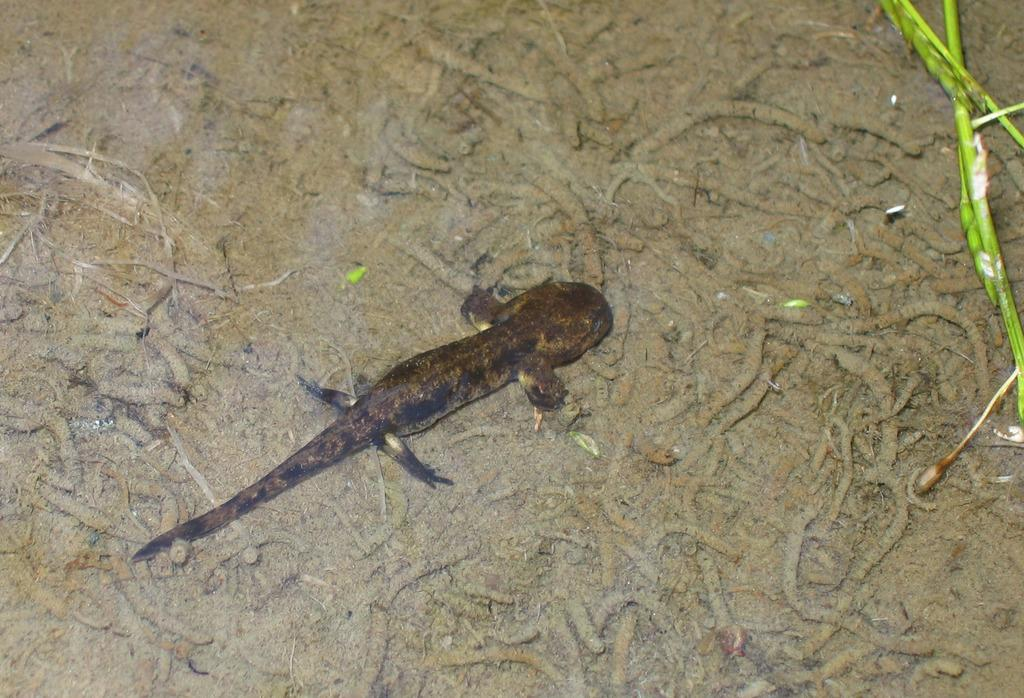What type of animal can be seen in the image? There is a lizard in the image. What other animals are present in the image? There are salamanders in the image. Where are the lizard and salamanders located in the image? Both the lizard and salamanders are on the ground. What type of spacecraft can be seen in the image? There is no spacecraft present in the image; it features a lizard and salamanders on the ground. Can you tell me how many hens are visible in the image? There are no hens present in the image. 